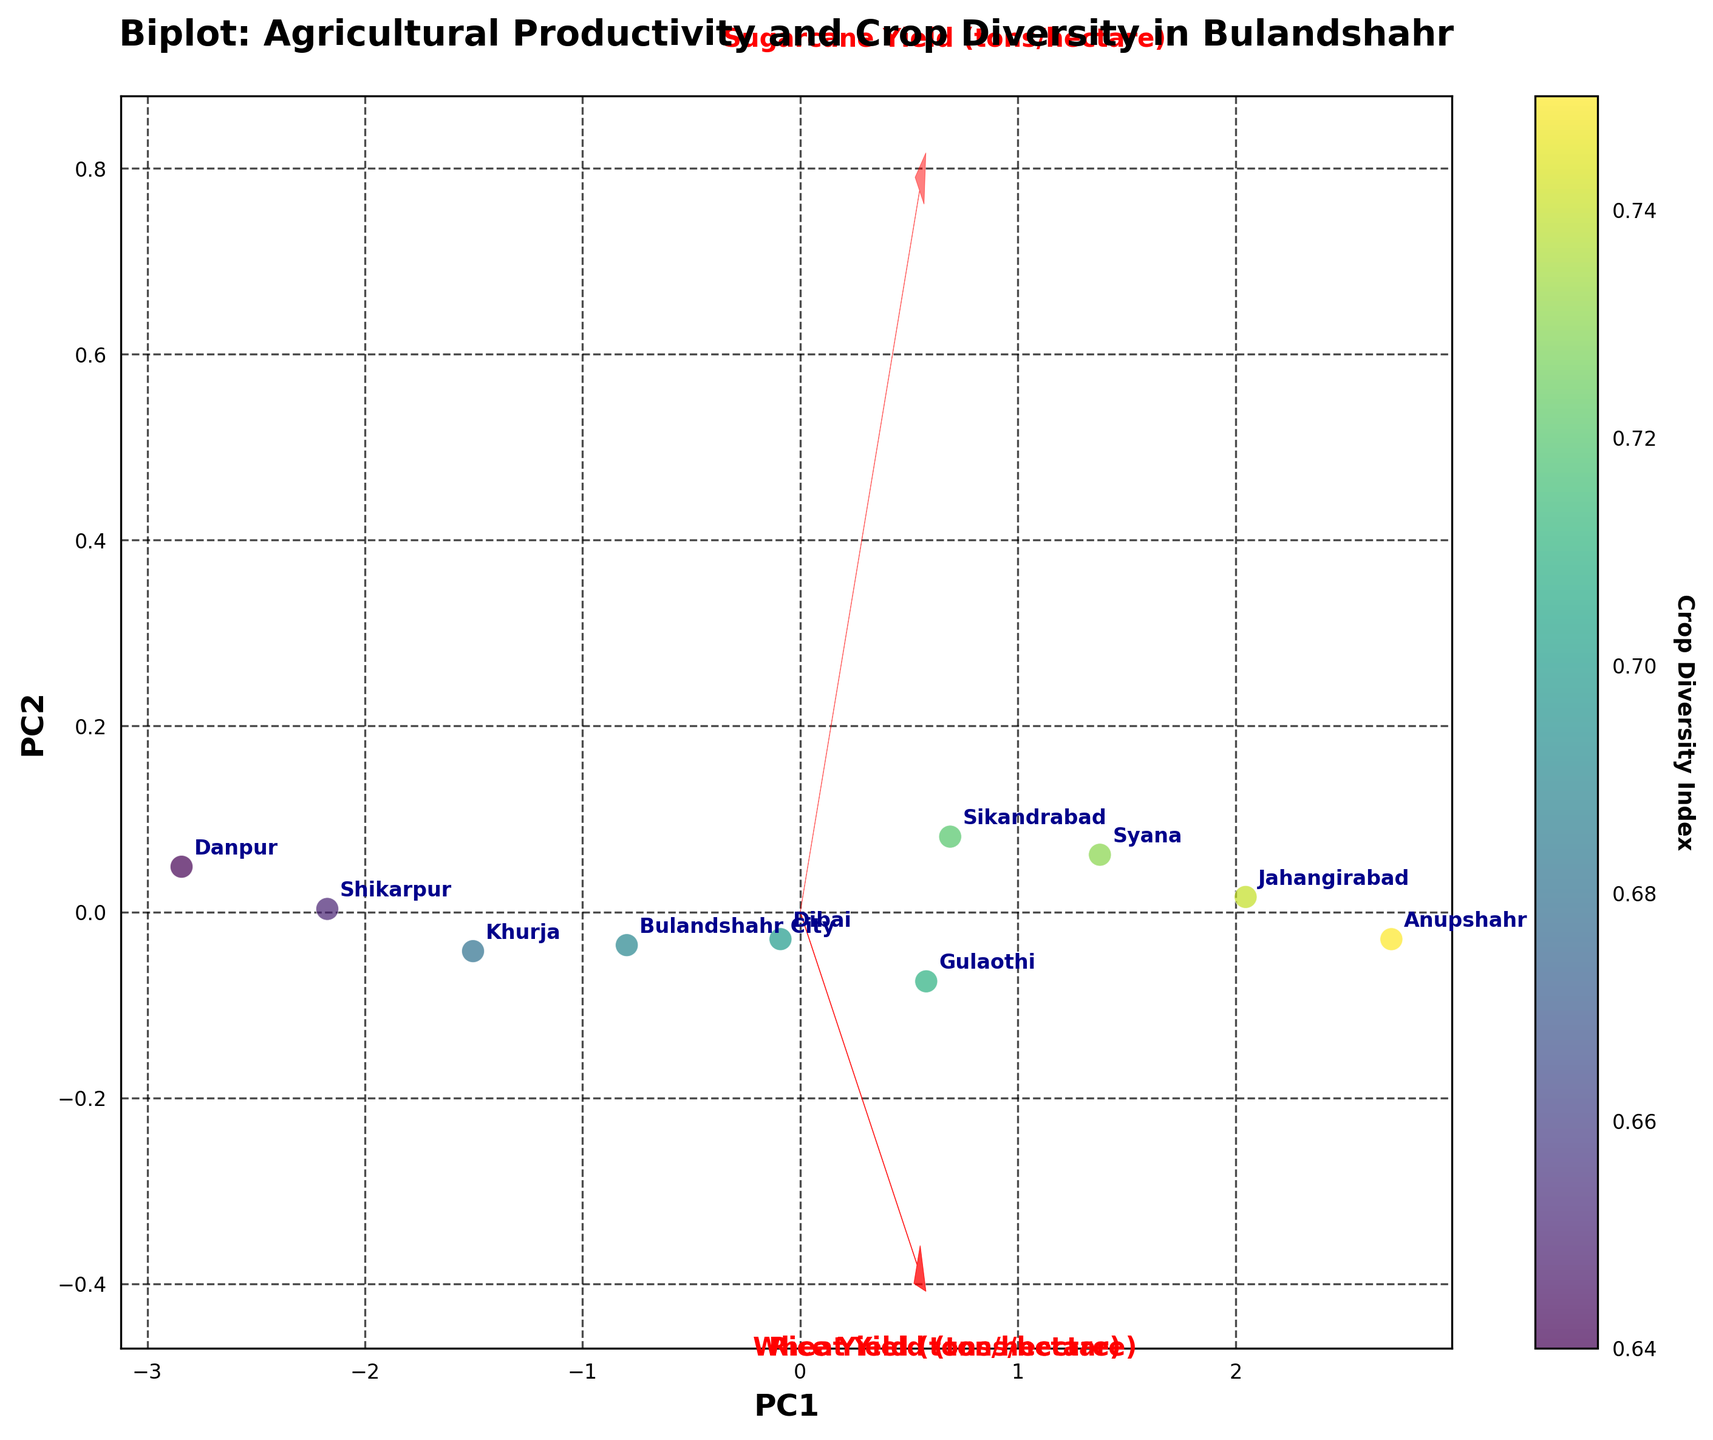Which region has the highest crop diversity index? Look for the region labels and the color gradient on the scatter points that indicate the Crop Diversity Index. Gulaothi has a high value as indicated by the colorbar.
Answer: Anupshahr How many regions are displayed in the plot? Count the number of data points labeled with region names on the scatter plot.
Answer: 10 Which crop's yield is most strongly associated with PC1? Look at the direction and length of the arrows. The longer the arrow in the direction of PC1, the stronger its association.
Answer: Wheat Which regions are closest to each other in terms of agricultural productivity and crop diversity? Observe the scatter points and find regions that are very close to each other.
Answer: Sikandrabad and Gulaothi Which region has the lowest agricultural productivity and why? Check which region has scatter points furthest from the origin and analyze the arrow directions. Danpur is farthest for all crops.
Answer: Danpur Is there a positive relationship between Wheat Yield and Rice Yield? Look at the direction of the arrows for Wheat Yield and Rice Yield. If they point in the same or similar direction, there is a positive relationship.
Answer: Yes Which crop has the most significant impact on PC2? Identify the arrow that is longest in the PC2 direction (vertical axis).
Answer: Sugarcane Compare the crop diversity index between Khurja and Syana. Look at the color gradient of the points labeled Khurja and Syana and compare them.
Answer: Syana has a higher index Which region appears to have balanced yields in Wheat, Rice, and Sugarcane? Find a region whose position in the plot is neither extremely high nor low in the directions of the arrows.
Answer: Bulandshahr City What does the length of the arrows in the Biplot represent? The longer the arrow, the stronger the influence of that variable on the principal components represented on the plot. Longer arrows indicate greater impact on either PC1 or PC2.
Answer: Influence of variables 